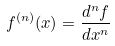Convert formula to latex. <formula><loc_0><loc_0><loc_500><loc_500>f ^ { ( n ) } ( x ) = \frac { d ^ { n } f } { d x ^ { n } }</formula> 